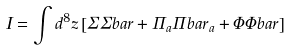<formula> <loc_0><loc_0><loc_500><loc_500>I = \int d ^ { 8 } z \left [ \Sigma \Sigma b a r + \Pi _ { a } \Pi b a r _ { a } + \Phi \Phi b a r \right ]</formula> 